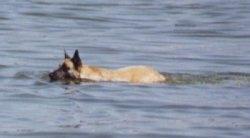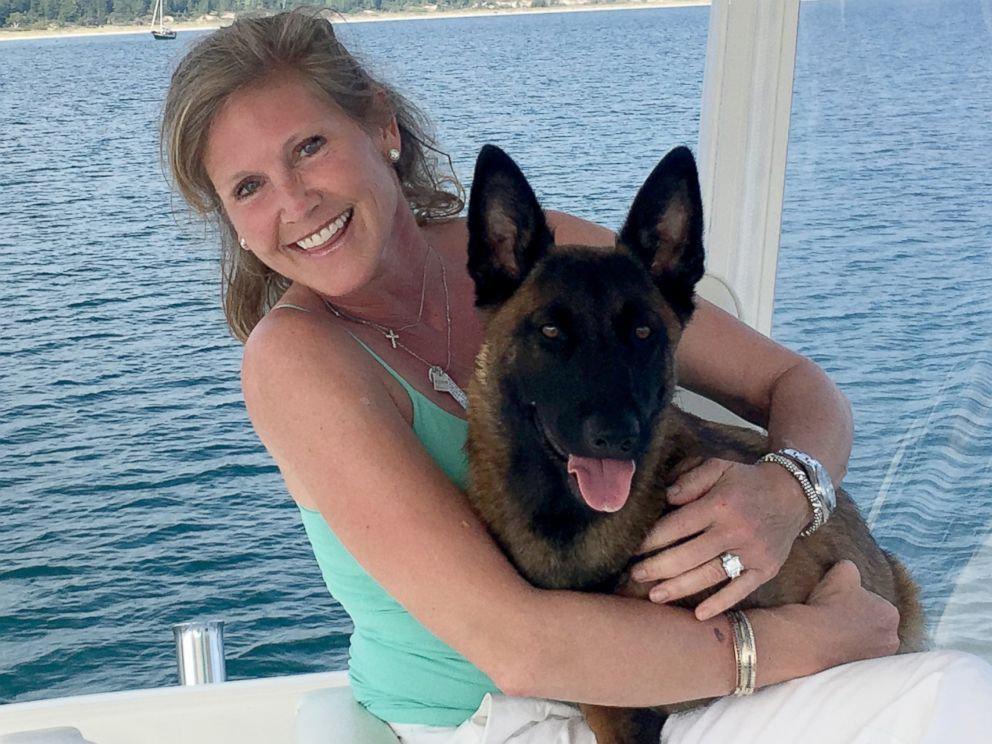The first image is the image on the left, the second image is the image on the right. Examine the images to the left and right. Is the description "A dog is in a jumping pose splashing over water, facing leftward with front paws extended." accurate? Answer yes or no. No. The first image is the image on the left, the second image is the image on the right. Examine the images to the left and right. Is the description "An image contains a dog jumping in water." accurate? Answer yes or no. No. 